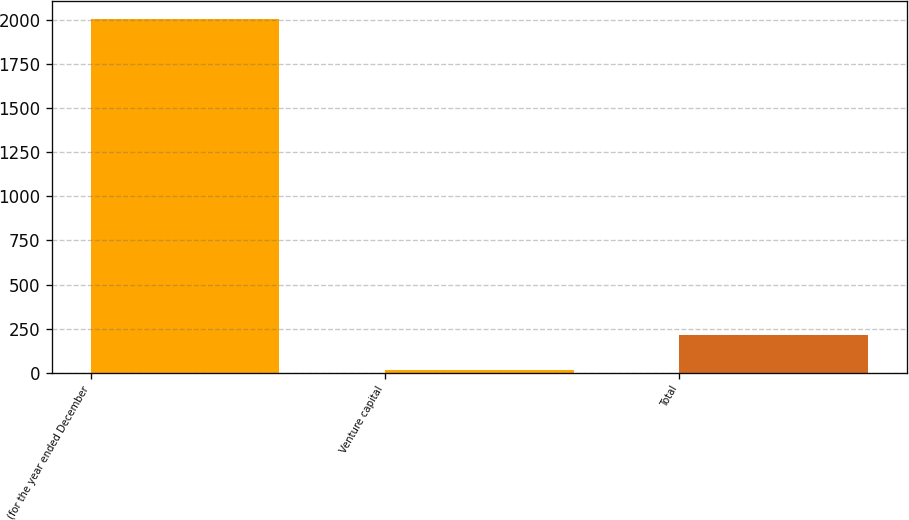Convert chart. <chart><loc_0><loc_0><loc_500><loc_500><bar_chart><fcel>(for the year ended December<fcel>Venture capital<fcel>Total<nl><fcel>2007<fcel>16<fcel>215.1<nl></chart> 